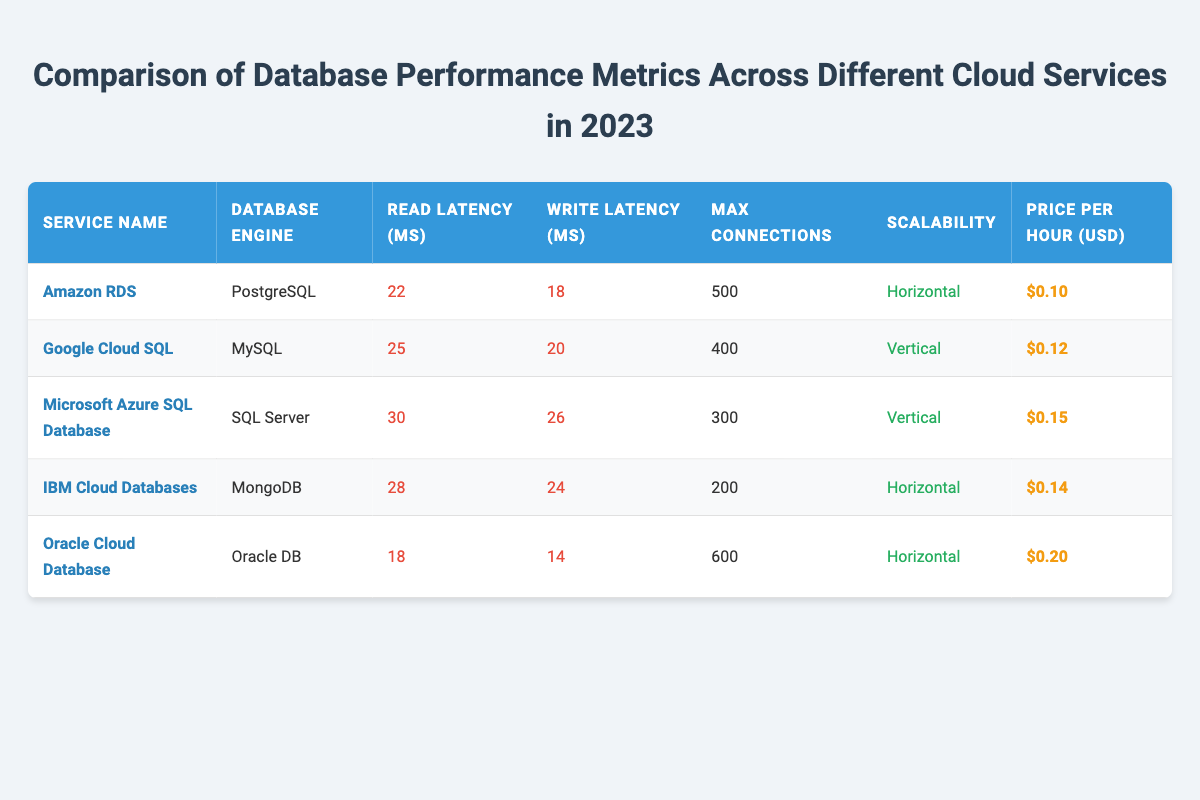What is the read latency for Google Cloud SQL? The value for read latency is directly listed under the "Read Latency (ms)" column for Google Cloud SQL, which is 25 milliseconds.
Answer: 25 milliseconds Which cloud service has the highest price per hour? By comparing the values in the "Price per Hour (USD)" column, Oracle Cloud Database has the highest value at 0.20 USD per hour, which is greater than all other services listed.
Answer: Oracle Cloud Database What is the average max connections across all cloud services? First, we sum the max connections: 500 + 400 + 300 + 200 + 600 = 2000. Then, we divide by the number of services (5): 2000 / 5 = 400.
Answer: 400 Does Amazon RDS have the lowest write latency among the services? Checking the "Write Latency (ms)" column, Amazon RDS has a latency of 18 milliseconds, which is lower than all the other listed services, thus confirming it does.
Answer: Yes Which service offers horizontal scalability and has the least read latency? Looking at the services with horizontal scalability, Amazon RDS (22 ms) and IBM Cloud Databases (28 ms) are the only two. Among these, Amazon RDS has the least read latency at 22 milliseconds.
Answer: Amazon RDS Is IBM Cloud Databases less expensive per hour than Google Cloud SQL? Comparing the price per hour, IBM Cloud Databases costs 0.14 USD, while Google Cloud SQL costs 0.12 USD. Since 0.14 is greater than 0.12, IBM Cloud Databases is not less expensive.
Answer: No What is the difference in read latency between Oracle Cloud Database and Microsoft Azure SQL Database? Oracle Cloud Database has a read latency of 18 ms, while Microsoft Azure SQL Database has 30 ms. The difference is 30 ms - 18 ms = 12 ms.
Answer: 12 ms Which database engine associated with the lowest write latency? The write latencies for each service are: Amazon RDS (18 ms), Google Cloud SQL (20 ms), Microsoft Azure SQL Database (26 ms), IBM Cloud Databases (24 ms), and Oracle Cloud Database (14 ms). Oracle Cloud Database has the lowest at 14 milliseconds.
Answer: Oracle DB 